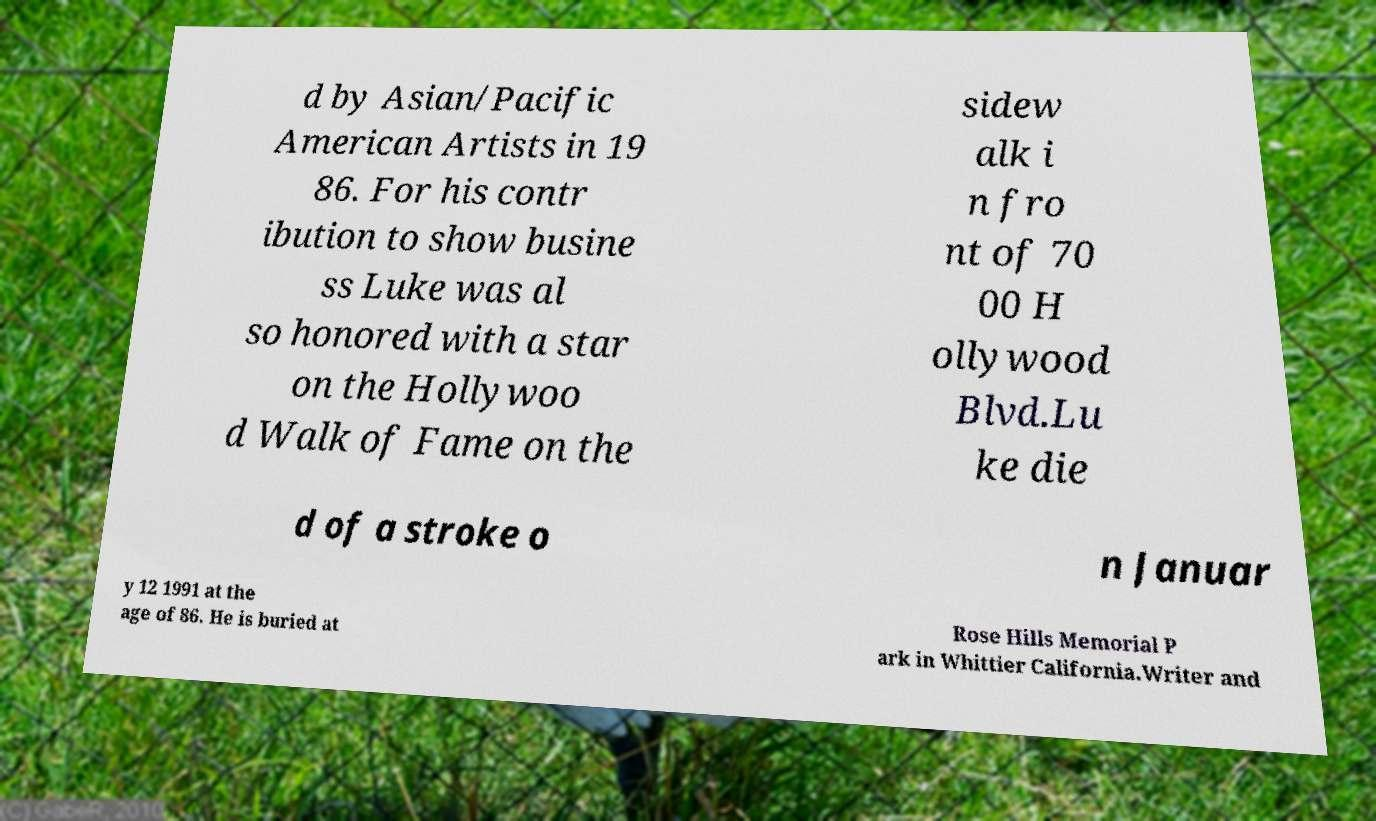For documentation purposes, I need the text within this image transcribed. Could you provide that? d by Asian/Pacific American Artists in 19 86. For his contr ibution to show busine ss Luke was al so honored with a star on the Hollywoo d Walk of Fame on the sidew alk i n fro nt of 70 00 H ollywood Blvd.Lu ke die d of a stroke o n Januar y 12 1991 at the age of 86. He is buried at Rose Hills Memorial P ark in Whittier California.Writer and 